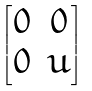Convert formula to latex. <formula><loc_0><loc_0><loc_500><loc_500>\begin{bmatrix} 0 & 0 \\ 0 & u \end{bmatrix}</formula> 